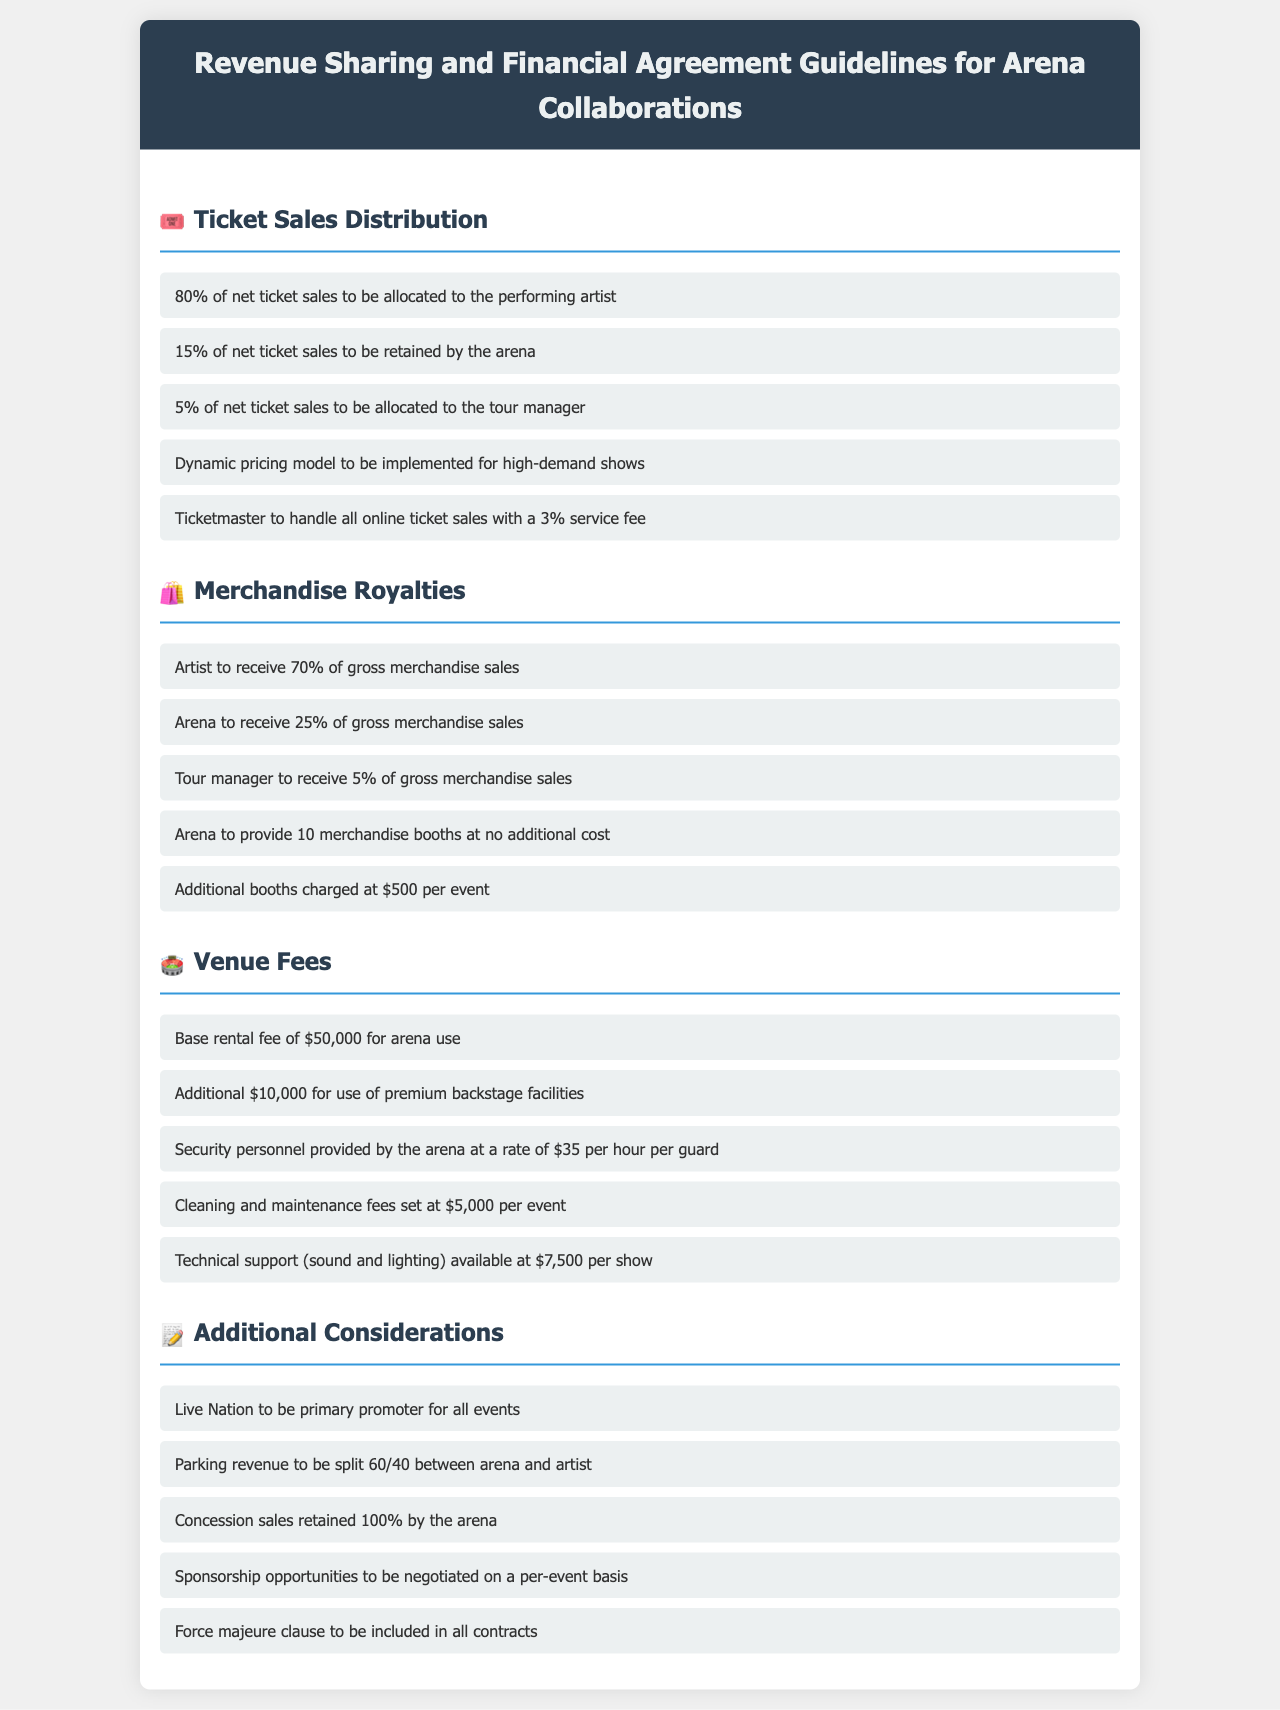What percentage of net ticket sales goes to the performing artist? The document states that 80% of net ticket sales are allocated to the performing artist.
Answer: 80% What is the venue's share of gross merchandise sales? According to the document, the arena receives 25% of gross merchandise sales.
Answer: 25% How much does the arena charge for additional merchandise booths? The document specifies a charge of $500 per event for additional booths.
Answer: $500 What is the base rental fee for arena use? The document lists the base rental fee for arena use as $50,000.
Answer: $50,000 What is the split ratio for parking revenue between arena and artist? The document mentions a split of 60/40 between the arena and the artist for parking revenue.
Answer: 60/40 How much does technical support cost per show? The document indicates that technical support is available at a cost of $7,500 per show.
Answer: $7,500 What is the service fee for Ticketmaster for online sales? The document states that there is a 3% service fee for Ticketmaster for online ticket sales.
Answer: 3% How many merchandise booths does the arena provide at no additional cost? The document specifies that the arena provides 10 merchandise booths at no additional cost.
Answer: 10 What additional fee is there for use of premium backstage facilities? According to the document, the additional fee for premium backstage facilities is $10,000.
Answer: $10,000 